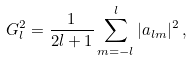Convert formula to latex. <formula><loc_0><loc_0><loc_500><loc_500>G _ { l } ^ { 2 } = \frac { 1 } { 2 l + 1 } \sum _ { m = - l } ^ { l } | a _ { l m } | ^ { 2 } \, ,</formula> 